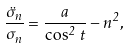<formula> <loc_0><loc_0><loc_500><loc_500>\frac { \ddot { \sigma } _ { n } } { \sigma _ { n } } = \frac { a } { \cos ^ { 2 } \, t } - n ^ { 2 } ,</formula> 